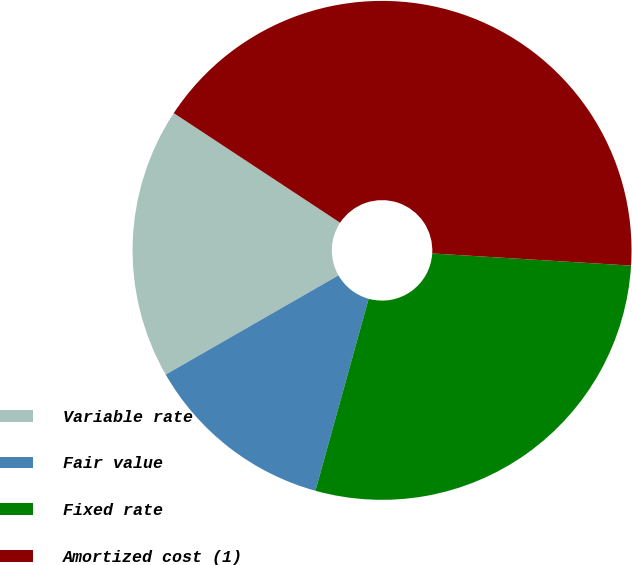Convert chart. <chart><loc_0><loc_0><loc_500><loc_500><pie_chart><fcel>Variable rate<fcel>Fair value<fcel>Fixed rate<fcel>Amortized cost (1)<nl><fcel>17.57%<fcel>12.4%<fcel>28.33%<fcel>41.7%<nl></chart> 